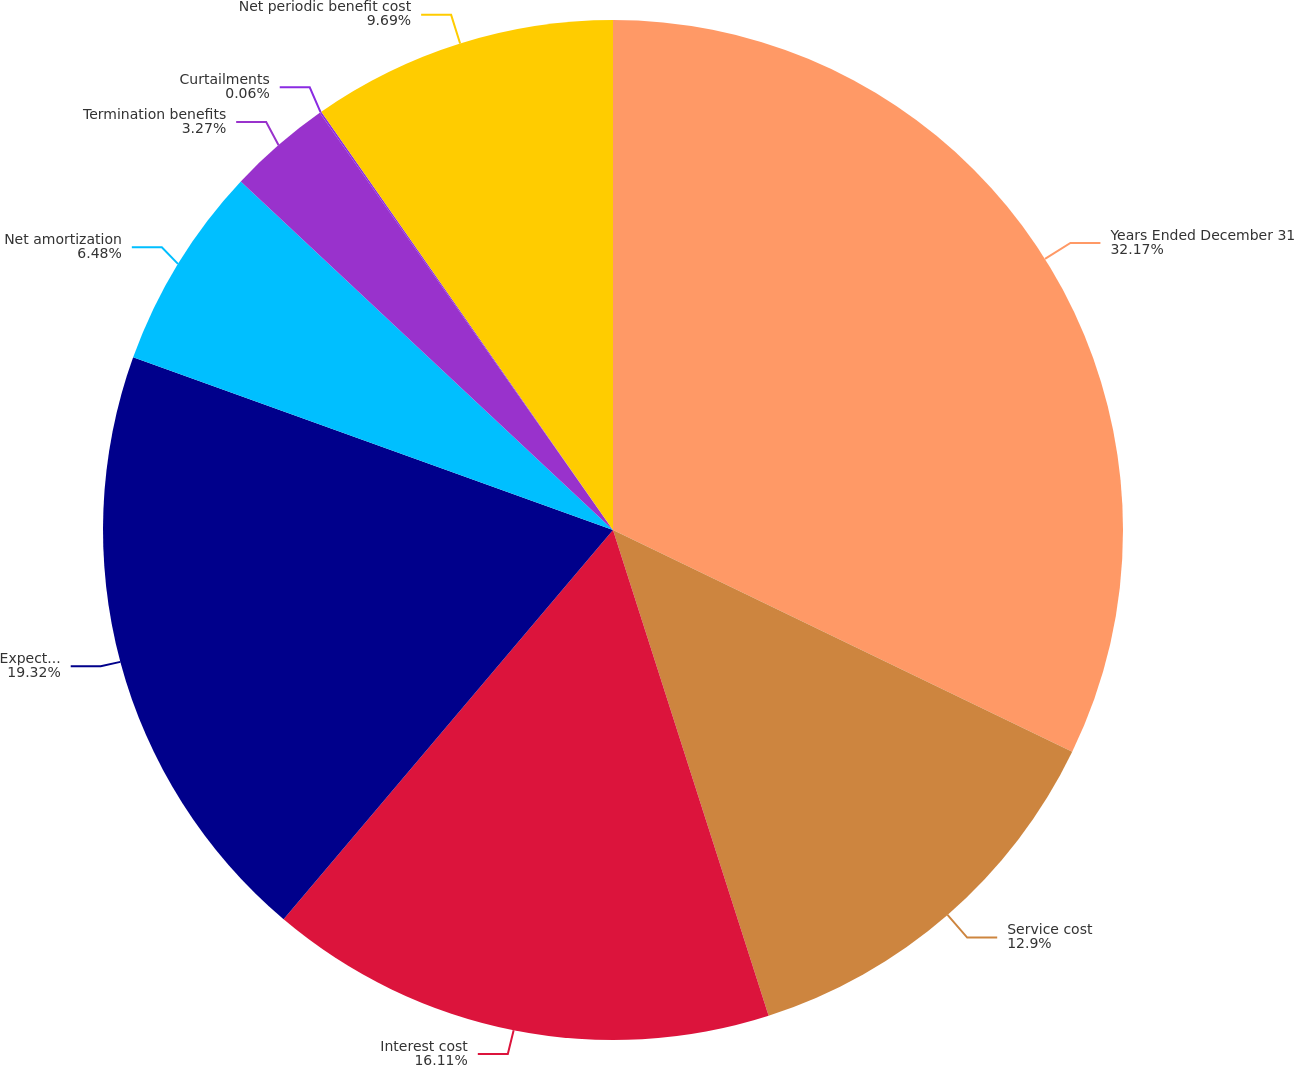Convert chart. <chart><loc_0><loc_0><loc_500><loc_500><pie_chart><fcel>Years Ended December 31<fcel>Service cost<fcel>Interest cost<fcel>Expected return on plan assets<fcel>Net amortization<fcel>Termination benefits<fcel>Curtailments<fcel>Net periodic benefit cost<nl><fcel>32.16%<fcel>12.9%<fcel>16.11%<fcel>19.32%<fcel>6.48%<fcel>3.27%<fcel>0.06%<fcel>9.69%<nl></chart> 